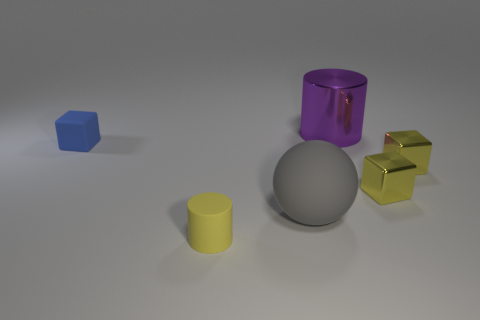Is there anything else that is the same shape as the large gray thing?
Give a very brief answer. No. How many small yellow matte cylinders are there?
Keep it short and to the point. 1. Is the ball the same size as the purple shiny thing?
Give a very brief answer. Yes. Are there any shiny objects that have the same color as the small rubber cylinder?
Offer a terse response. Yes. There is a tiny matte thing that is to the left of the matte cylinder; is its shape the same as the large rubber object?
Offer a very short reply. No. What number of yellow rubber spheres have the same size as the gray sphere?
Your answer should be compact. 0. What number of purple metal things are behind the cylinder to the right of the yellow cylinder?
Your answer should be very brief. 0. Is the tiny object that is on the left side of the tiny yellow rubber thing made of the same material as the large purple thing?
Keep it short and to the point. No. Are the big object behind the blue matte thing and the tiny cube that is to the left of the large matte sphere made of the same material?
Give a very brief answer. No. Is the number of tiny rubber objects that are behind the tiny blue block greater than the number of big gray matte objects?
Your response must be concise. No. 